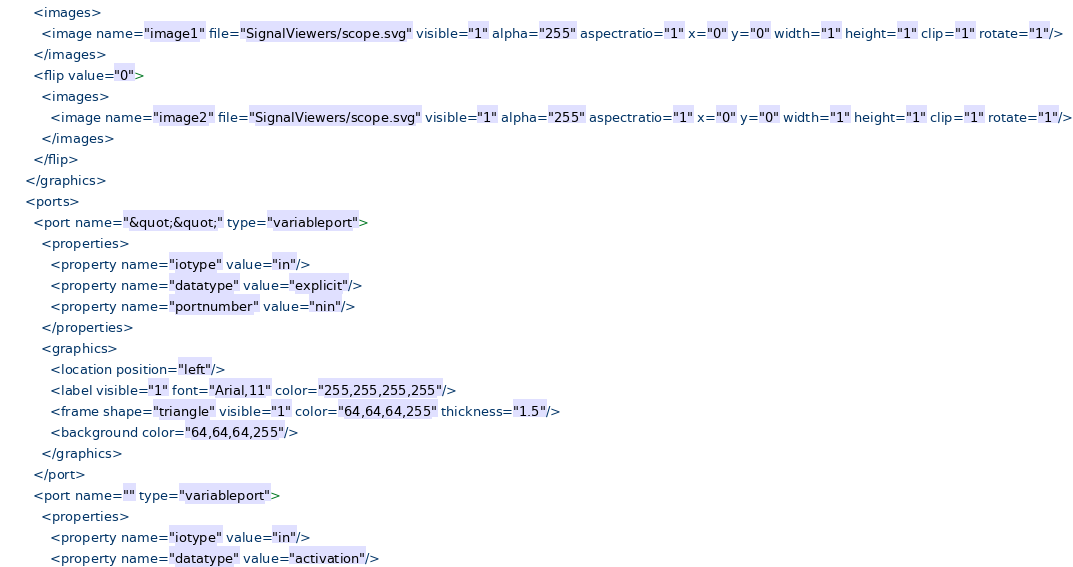Convert code to text. <code><loc_0><loc_0><loc_500><loc_500><_Scheme_>        <images>
          <image name="image1" file="SignalViewers/scope.svg" visible="1" alpha="255" aspectratio="1" x="0" y="0" width="1" height="1" clip="1" rotate="1"/>
        </images>
        <flip value="0">
          <images>
            <image name="image2" file="SignalViewers/scope.svg" visible="1" alpha="255" aspectratio="1" x="0" y="0" width="1" height="1" clip="1" rotate="1"/>
          </images>
        </flip>
      </graphics>
      <ports>
        <port name="&quot;&quot;" type="variableport">
          <properties>
            <property name="iotype" value="in"/>
            <property name="datatype" value="explicit"/>
            <property name="portnumber" value="nin"/>
          </properties>
          <graphics>
            <location position="left"/>
            <label visible="1" font="Arial,11" color="255,255,255,255"/>
            <frame shape="triangle" visible="1" color="64,64,64,255" thickness="1.5"/>
            <background color="64,64,64,255"/>
          </graphics>
        </port>
        <port name="" type="variableport">
          <properties>
            <property name="iotype" value="in"/>
            <property name="datatype" value="activation"/></code> 